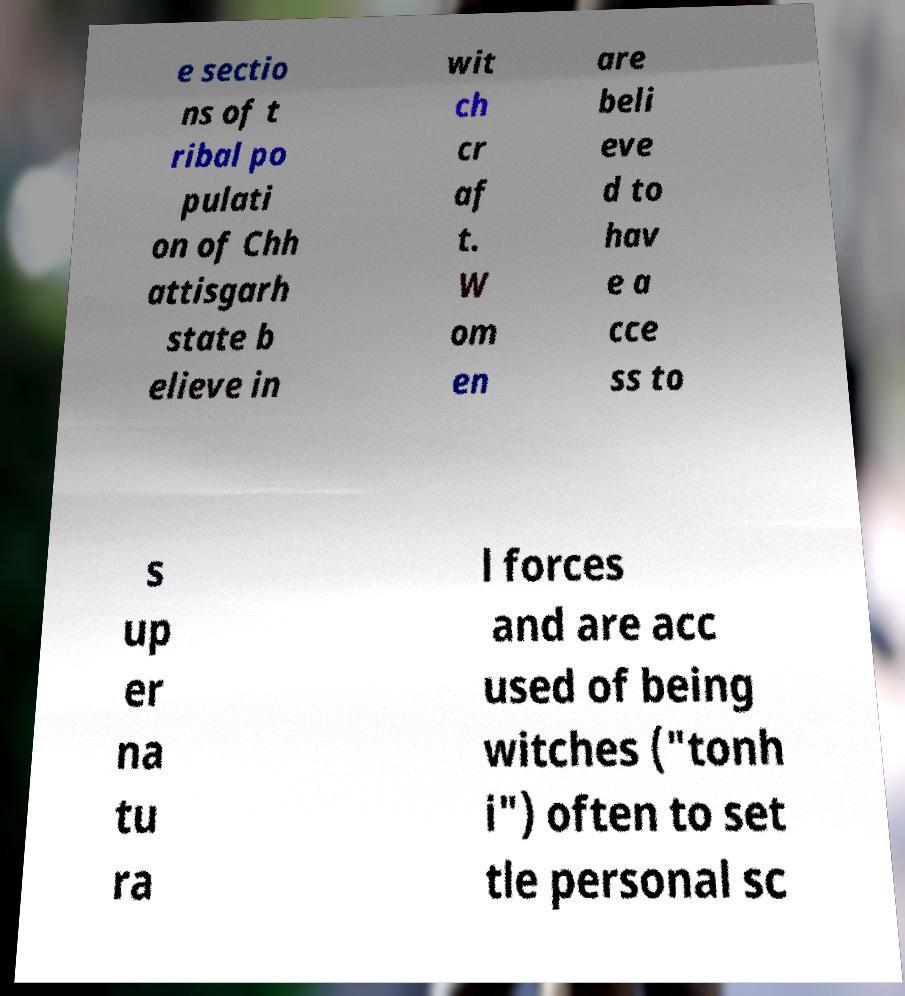Please identify and transcribe the text found in this image. e sectio ns of t ribal po pulati on of Chh attisgarh state b elieve in wit ch cr af t. W om en are beli eve d to hav e a cce ss to s up er na tu ra l forces and are acc used of being witches ("tonh i") often to set tle personal sc 